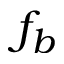Convert formula to latex. <formula><loc_0><loc_0><loc_500><loc_500>f _ { b }</formula> 